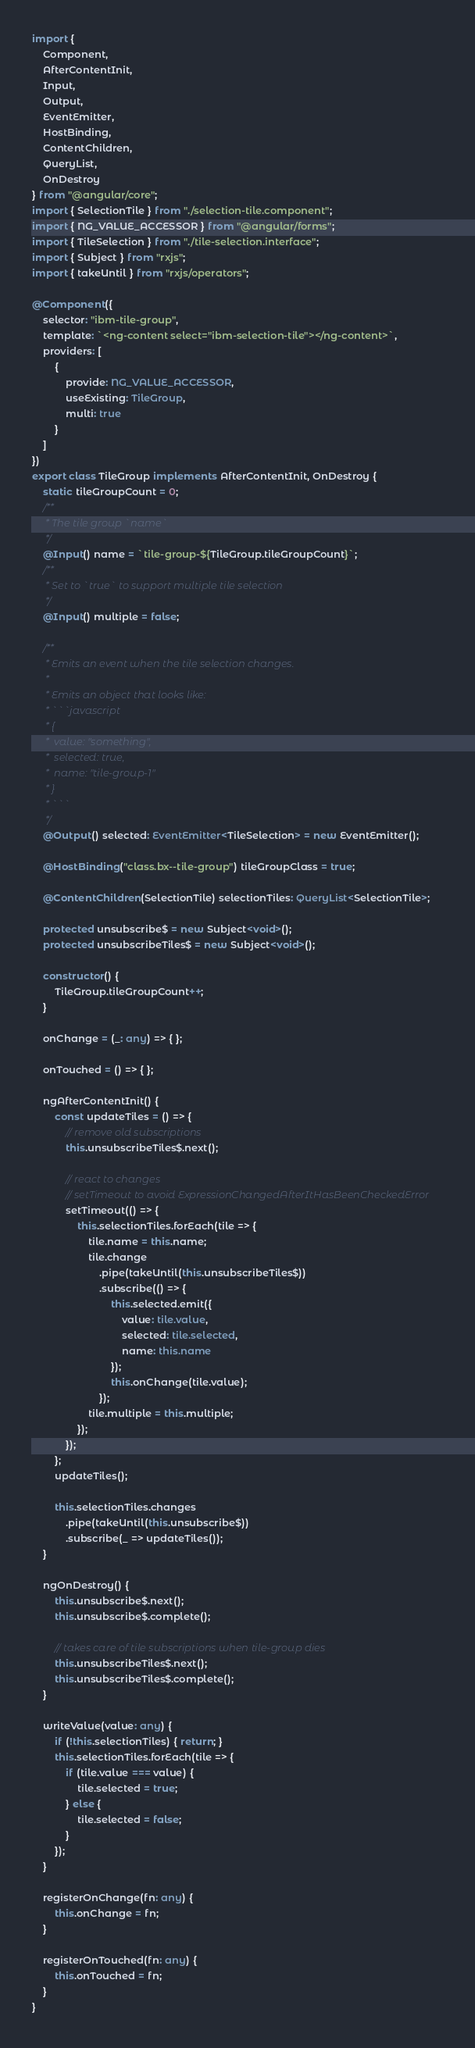<code> <loc_0><loc_0><loc_500><loc_500><_TypeScript_>import {
	Component,
	AfterContentInit,
	Input,
	Output,
	EventEmitter,
	HostBinding,
	ContentChildren,
	QueryList,
	OnDestroy
} from "@angular/core";
import { SelectionTile } from "./selection-tile.component";
import { NG_VALUE_ACCESSOR } from "@angular/forms";
import { TileSelection } from "./tile-selection.interface";
import { Subject } from "rxjs";
import { takeUntil } from "rxjs/operators";

@Component({
	selector: "ibm-tile-group",
	template: `<ng-content select="ibm-selection-tile"></ng-content>`,
	providers: [
		{
			provide: NG_VALUE_ACCESSOR,
			useExisting: TileGroup,
			multi: true
		}
	]
})
export class TileGroup implements AfterContentInit, OnDestroy {
	static tileGroupCount = 0;
	/**
	 * The tile group `name`
	 */
	@Input() name = `tile-group-${TileGroup.tileGroupCount}`;
	/**
	 * Set to `true` to support multiple tile selection
	 */
	@Input() multiple = false;

	/**
	 * Emits an event when the tile selection changes.
	 *
	 * Emits an object that looks like:
	 * ```javascript
	 * {
	 * 	value: "something",
	 * 	selected: true,
	 * 	name: "tile-group-1"
	 * }
	 * ```
	 */
	@Output() selected: EventEmitter<TileSelection> = new EventEmitter();

	@HostBinding("class.bx--tile-group") tileGroupClass = true;

	@ContentChildren(SelectionTile) selectionTiles: QueryList<SelectionTile>;

	protected unsubscribe$ = new Subject<void>();
	protected unsubscribeTiles$ = new Subject<void>();

	constructor() {
		TileGroup.tileGroupCount++;
	}

	onChange = (_: any) => { };

	onTouched = () => { };

	ngAfterContentInit() {
		const updateTiles = () => {
			// remove old subscriptions
			this.unsubscribeTiles$.next();

			// react to changes
			// setTimeout to avoid ExpressionChangedAfterItHasBeenCheckedError
			setTimeout(() => {
				this.selectionTiles.forEach(tile => {
					tile.name = this.name;
					tile.change
						.pipe(takeUntil(this.unsubscribeTiles$))
						.subscribe(() => {
							this.selected.emit({
								value: tile.value,
								selected: tile.selected,
								name: this.name
							});
							this.onChange(tile.value);
						});
					tile.multiple = this.multiple;
				});
			});
		};
		updateTiles();

		this.selectionTiles.changes
			.pipe(takeUntil(this.unsubscribe$))
			.subscribe(_ => updateTiles());
	}

	ngOnDestroy() {
		this.unsubscribe$.next();
		this.unsubscribe$.complete();

		// takes care of tile subscriptions when tile-group dies
		this.unsubscribeTiles$.next();
		this.unsubscribeTiles$.complete();
	}

	writeValue(value: any) {
		if (!this.selectionTiles) { return; }
		this.selectionTiles.forEach(tile => {
			if (tile.value === value) {
				tile.selected = true;
			} else {
				tile.selected = false;
			}
		});
	}

	registerOnChange(fn: any) {
		this.onChange = fn;
	}

	registerOnTouched(fn: any) {
		this.onTouched = fn;
	}
}
</code> 